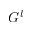<formula> <loc_0><loc_0><loc_500><loc_500>G ^ { l }</formula> 